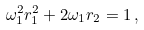<formula> <loc_0><loc_0><loc_500><loc_500>\omega _ { 1 } ^ { 2 } r _ { 1 } ^ { 2 } + 2 \omega _ { 1 } r _ { 2 } = 1 \, ,</formula> 